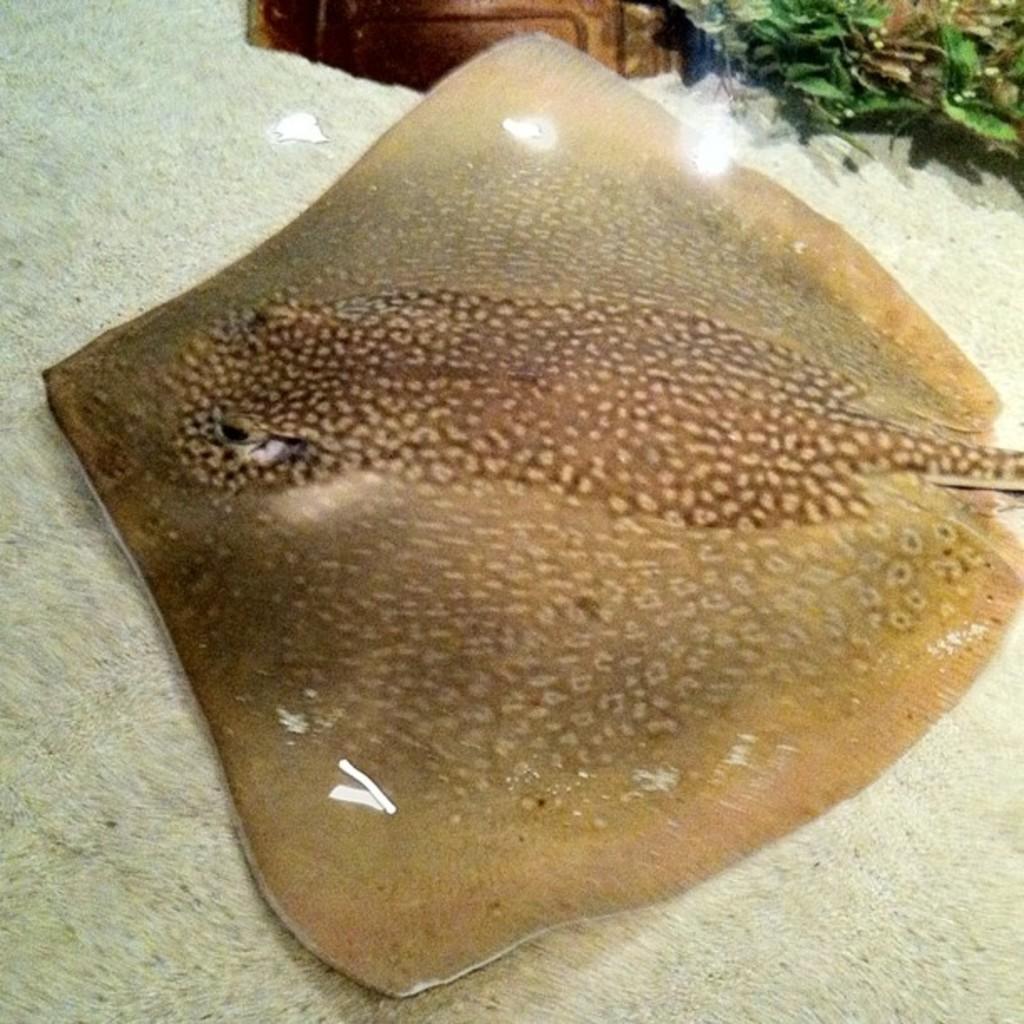Please provide a concise description of this image. In this image I can see an aquatic animal which is in brown color. To the side I can see the plants and brown color object. These are on the white color surface. 